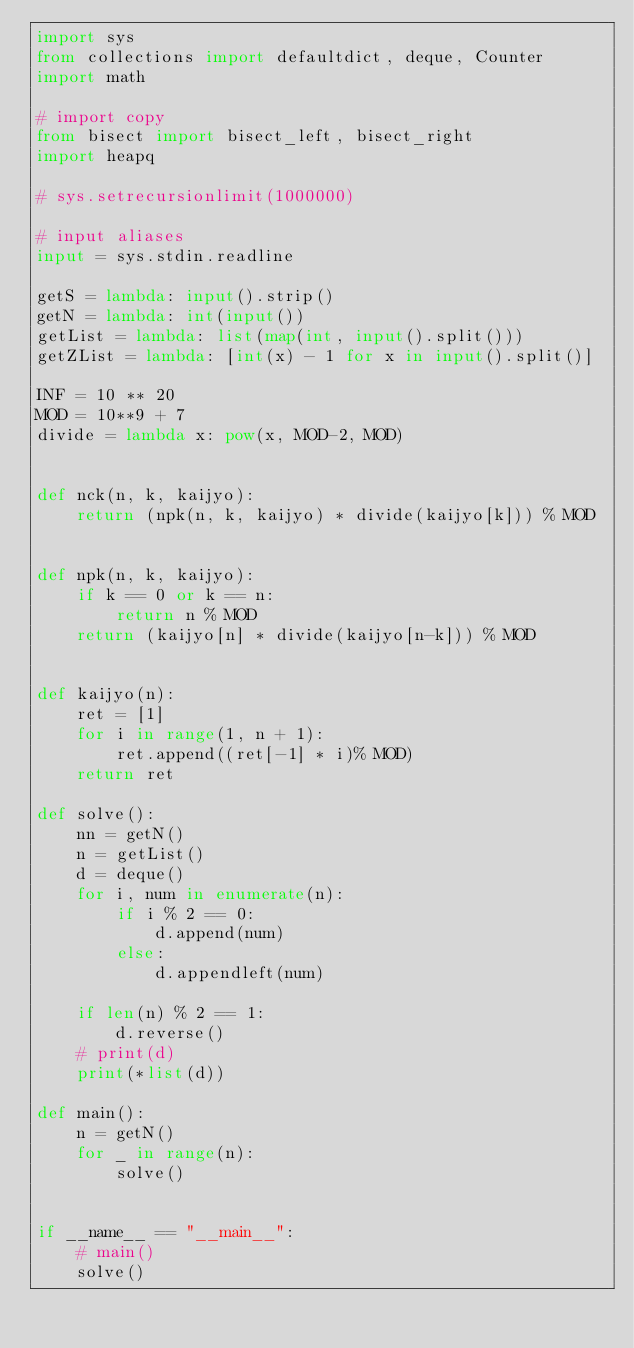Convert code to text. <code><loc_0><loc_0><loc_500><loc_500><_Python_>import sys
from collections import defaultdict, deque, Counter
import math

# import copy
from bisect import bisect_left, bisect_right
import heapq

# sys.setrecursionlimit(1000000)

# input aliases
input = sys.stdin.readline

getS = lambda: input().strip()
getN = lambda: int(input())
getList = lambda: list(map(int, input().split()))
getZList = lambda: [int(x) - 1 for x in input().split()]

INF = 10 ** 20
MOD = 10**9 + 7
divide = lambda x: pow(x, MOD-2, MOD)


def nck(n, k, kaijyo):
    return (npk(n, k, kaijyo) * divide(kaijyo[k])) % MOD


def npk(n, k, kaijyo):
    if k == 0 or k == n:
        return n % MOD
    return (kaijyo[n] * divide(kaijyo[n-k])) % MOD


def kaijyo(n):
    ret = [1]
    for i in range(1, n + 1):
        ret.append((ret[-1] * i)% MOD)
    return ret

def solve():
    nn = getN()
    n = getList()
    d = deque()
    for i, num in enumerate(n):
        if i % 2 == 0:
            d.append(num)
        else:
            d.appendleft(num)

    if len(n) % 2 == 1:
        d.reverse()
    # print(d)
    print(*list(d))

def main():
    n = getN()
    for _ in range(n):
        solve()


if __name__ == "__main__":
    # main()
    solve()</code> 